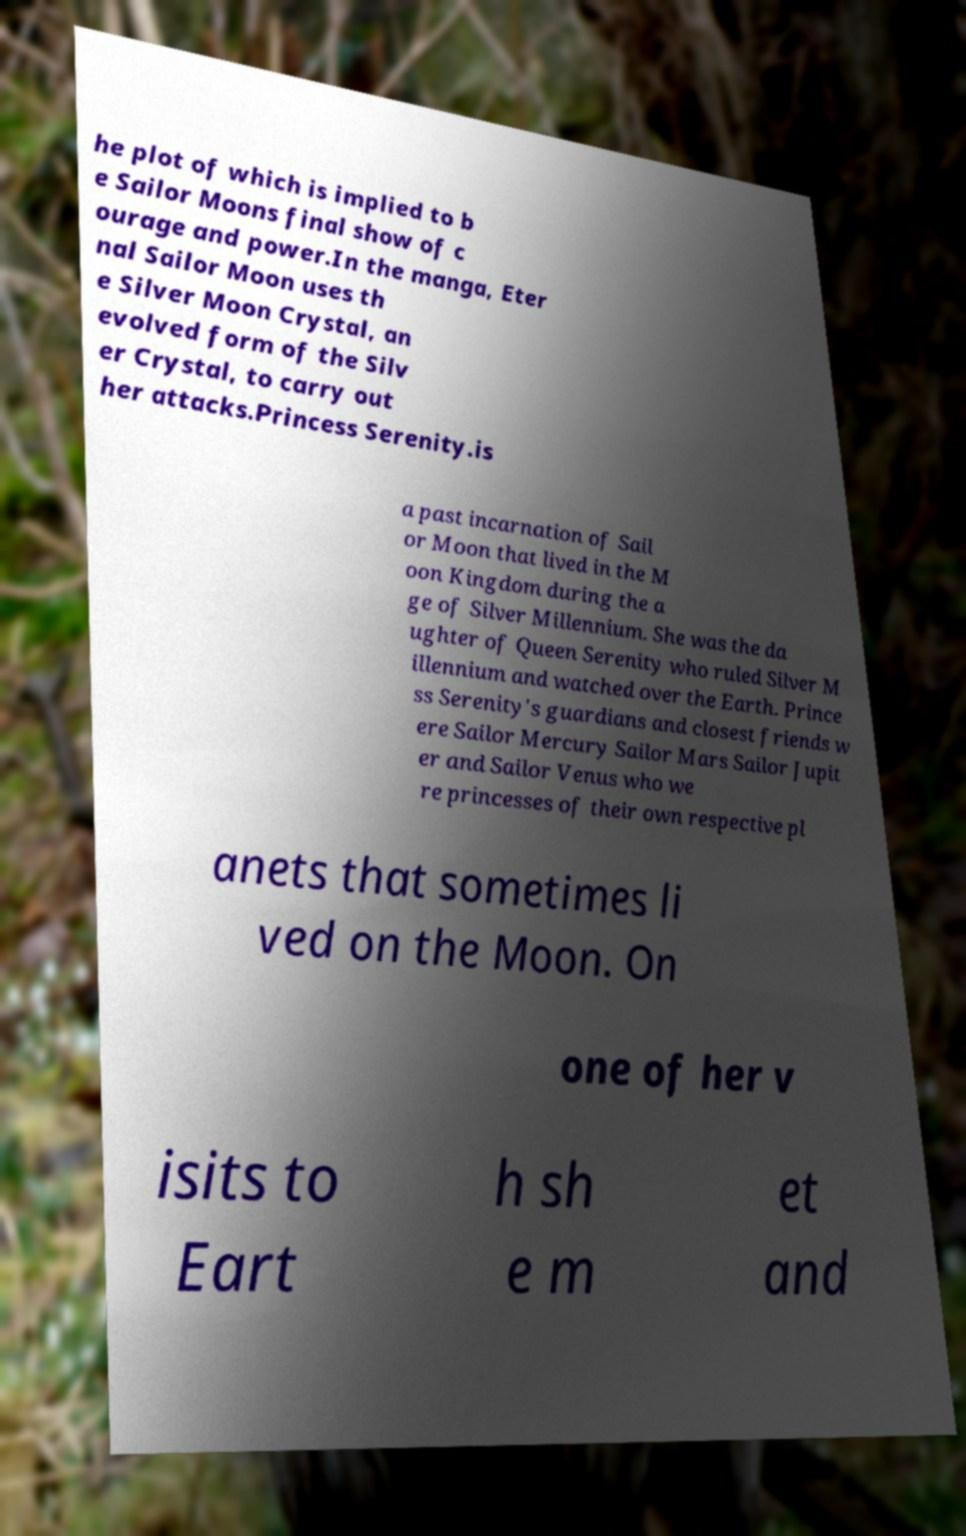I need the written content from this picture converted into text. Can you do that? he plot of which is implied to b e Sailor Moons final show of c ourage and power.In the manga, Eter nal Sailor Moon uses th e Silver Moon Crystal, an evolved form of the Silv er Crystal, to carry out her attacks.Princess Serenity.is a past incarnation of Sail or Moon that lived in the M oon Kingdom during the a ge of Silver Millennium. She was the da ughter of Queen Serenity who ruled Silver M illennium and watched over the Earth. Prince ss Serenity's guardians and closest friends w ere Sailor Mercury Sailor Mars Sailor Jupit er and Sailor Venus who we re princesses of their own respective pl anets that sometimes li ved on the Moon. On one of her v isits to Eart h sh e m et and 